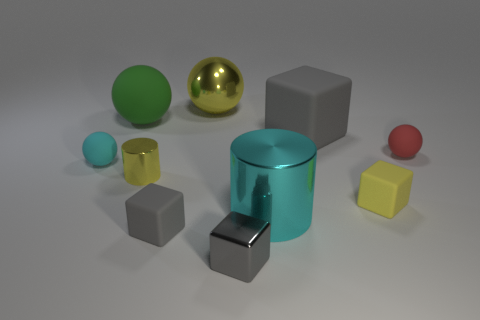What is the material of the small cylinder that is the same color as the shiny ball?
Provide a succinct answer. Metal. Are there any red spheres to the left of the gray matte object behind the cyan sphere?
Provide a succinct answer. No. Is the number of small cyan objects that are in front of the small gray metal cube less than the number of tiny gray metal blocks?
Give a very brief answer. Yes. Is the material of the ball right of the metallic block the same as the green object?
Offer a very short reply. Yes. There is a small cylinder that is the same material as the big cyan cylinder; what color is it?
Your answer should be compact. Yellow. Is the number of tiny cyan matte balls that are right of the big yellow thing less than the number of yellow rubber things that are to the left of the tiny yellow cylinder?
Keep it short and to the point. No. There is a shiny block that is to the right of the cyan ball; is its color the same as the cube that is behind the small red rubber ball?
Make the answer very short. Yes. Are there any tiny red objects made of the same material as the cyan cylinder?
Provide a succinct answer. No. There is a cyan object on the left side of the tiny metal object that is on the left side of the gray metallic object; what is its size?
Make the answer very short. Small. Are there more red spheres than large gray metal objects?
Offer a very short reply. Yes. 